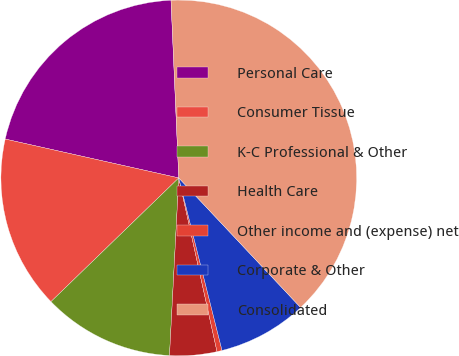Convert chart. <chart><loc_0><loc_0><loc_500><loc_500><pie_chart><fcel>Personal Care<fcel>Consumer Tissue<fcel>K-C Professional & Other<fcel>Health Care<fcel>Other income and (expense) net<fcel>Corporate & Other<fcel>Consolidated<nl><fcel>20.8%<fcel>15.75%<fcel>11.93%<fcel>4.28%<fcel>0.46%<fcel>8.1%<fcel>38.69%<nl></chart> 